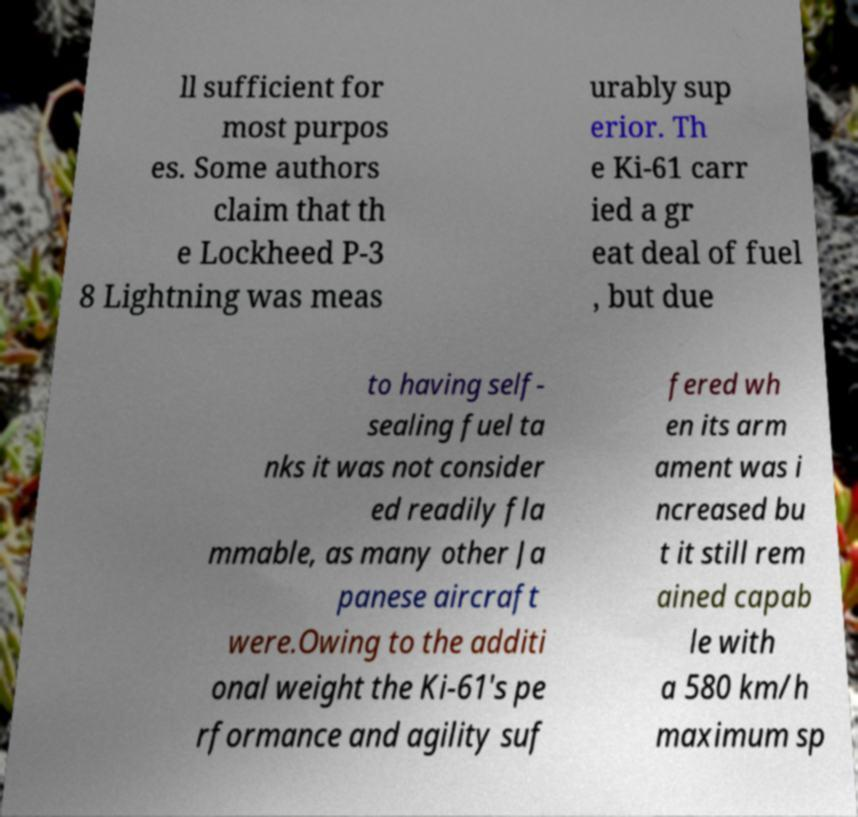Could you assist in decoding the text presented in this image and type it out clearly? ll sufficient for most purpos es. Some authors claim that th e Lockheed P-3 8 Lightning was meas urably sup erior. Th e Ki-61 carr ied a gr eat deal of fuel , but due to having self- sealing fuel ta nks it was not consider ed readily fla mmable, as many other Ja panese aircraft were.Owing to the additi onal weight the Ki-61's pe rformance and agility suf fered wh en its arm ament was i ncreased bu t it still rem ained capab le with a 580 km/h maximum sp 